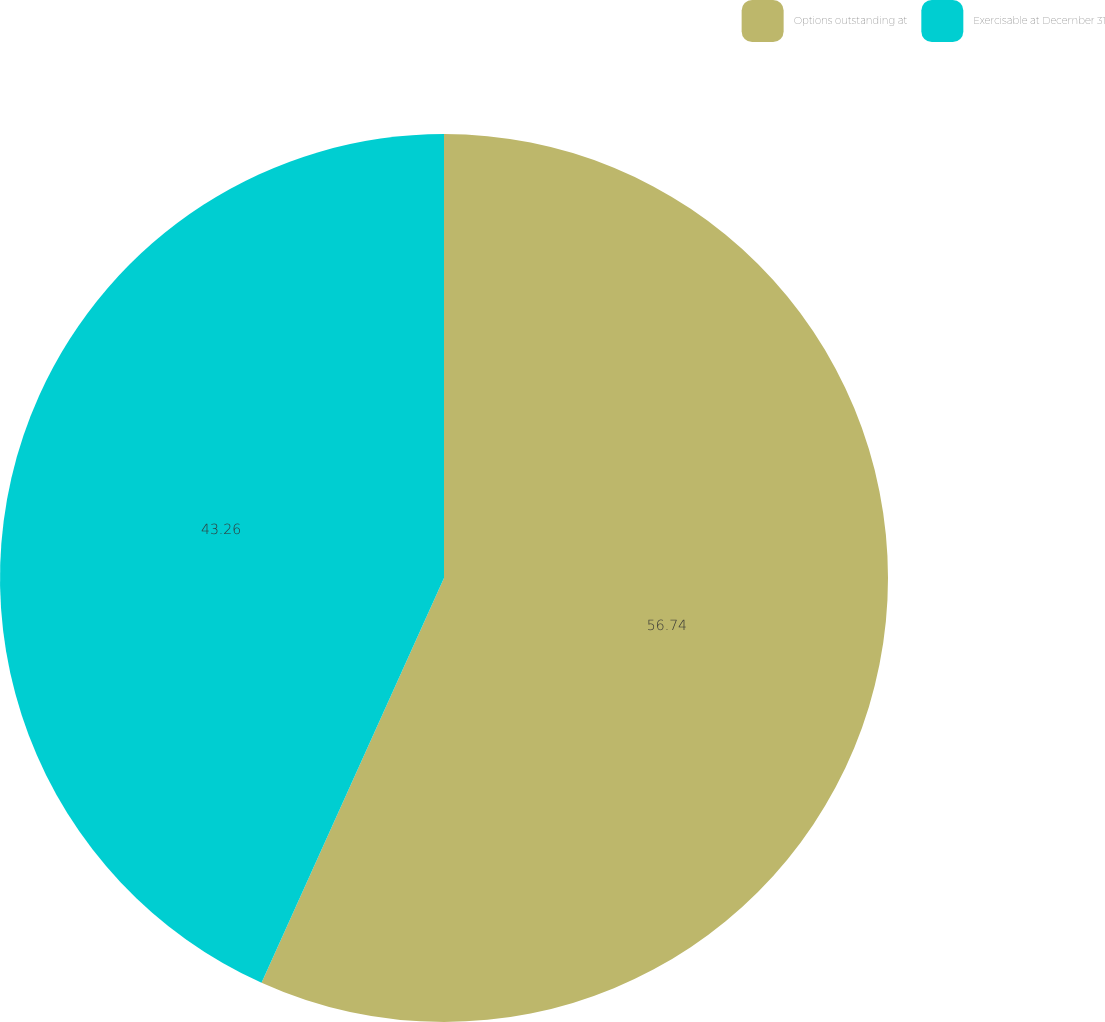Convert chart. <chart><loc_0><loc_0><loc_500><loc_500><pie_chart><fcel>Options outstanding at<fcel>Exercisable at December 31<nl><fcel>56.74%<fcel>43.26%<nl></chart> 